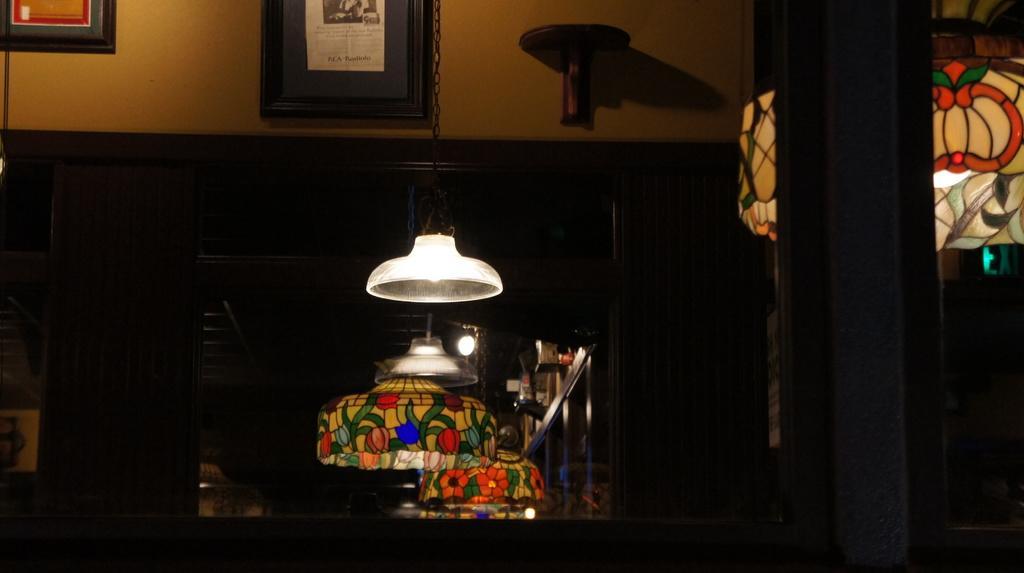How would you summarize this image in a sentence or two? In this image we can see some lamps. On the backside we can see a photo frame on the wall and a mirror. 